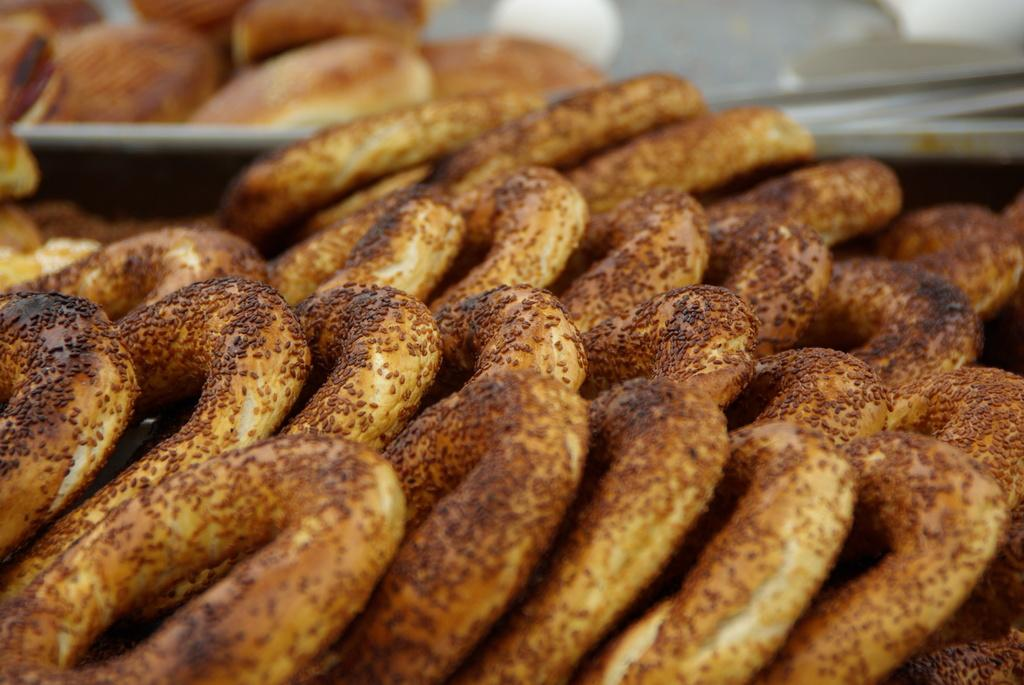What type of food items can be seen in the image? There are snacks in the image. What is used to hold or serve the snacks? There is a plate in the image. What type of drink is being offered in the image? There is no drink present in the image; only snacks and a plate are visible. 